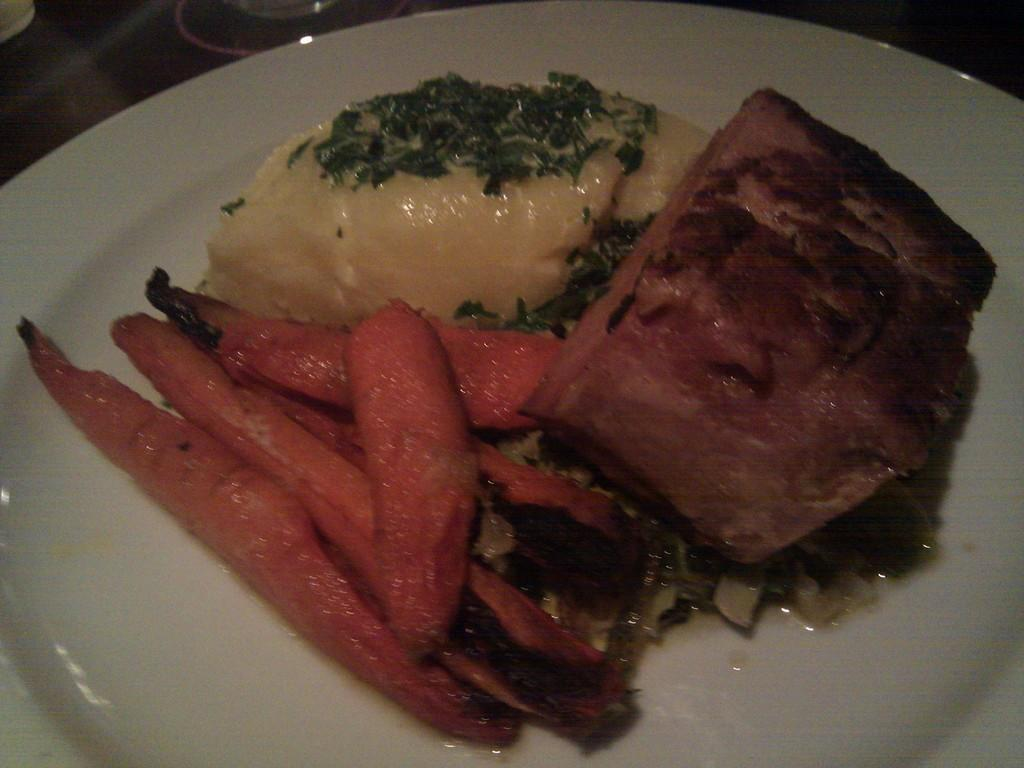What type of food is present in the image? There is food containing meat in the image. What vegetable is included in the food? There are carrot slices in the food. How is the food arranged in the image? The food is in a plate. Where is the plate located in the image? The plate is placed on a table. How many bikes are parked next to the table in the image? There are no bikes present in the image. 